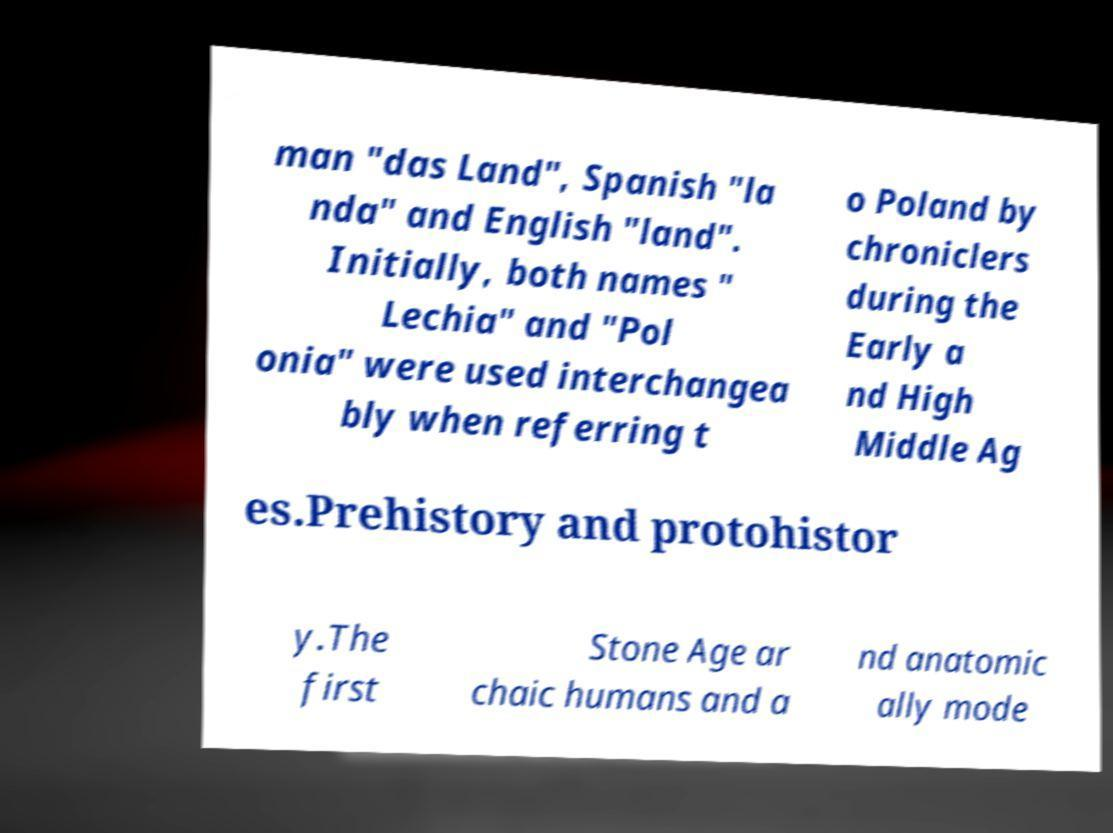There's text embedded in this image that I need extracted. Can you transcribe it verbatim? man "das Land", Spanish "la nda" and English "land". Initially, both names " Lechia" and "Pol onia" were used interchangea bly when referring t o Poland by chroniclers during the Early a nd High Middle Ag es.Prehistory and protohistor y.The first Stone Age ar chaic humans and a nd anatomic ally mode 